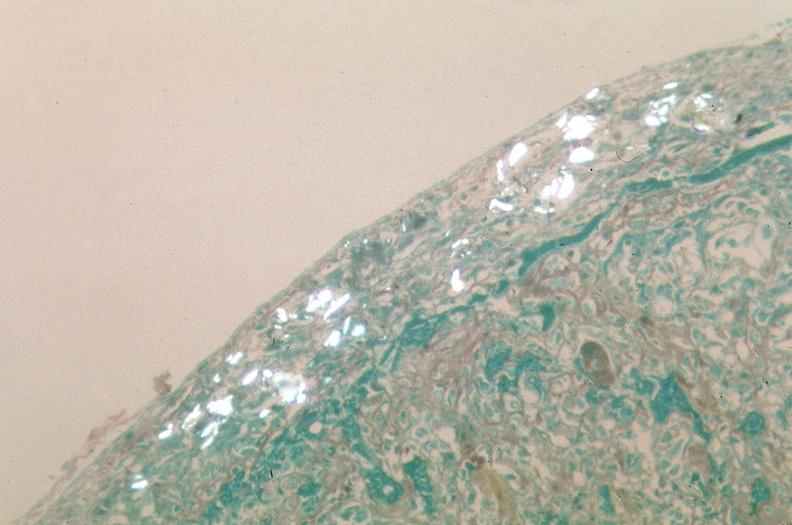s respiratory present?
Answer the question using a single word or phrase. Yes 